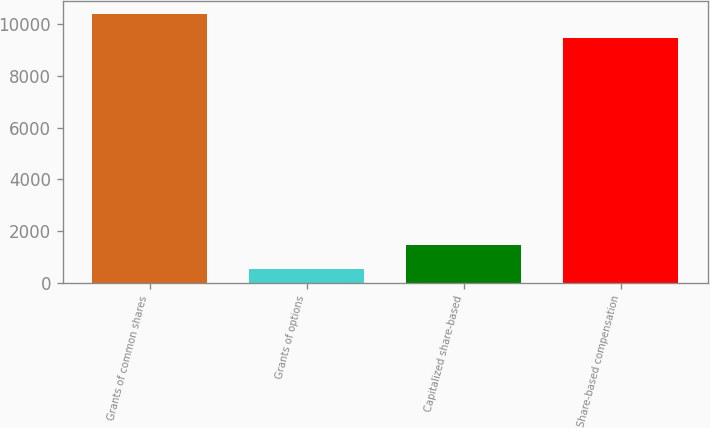Convert chart to OTSL. <chart><loc_0><loc_0><loc_500><loc_500><bar_chart><fcel>Grants of common shares<fcel>Grants of options<fcel>Capitalized share-based<fcel>Share-based compensation<nl><fcel>10395.1<fcel>525<fcel>1457.1<fcel>9463<nl></chart> 